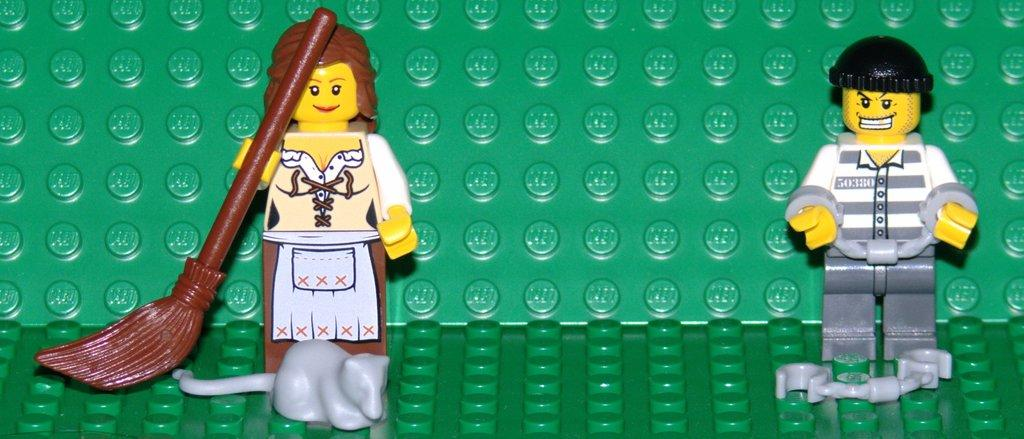What type of toys are present in the image? The toys in the image are made of Lego sets. Can you describe the material used to create these toys? The toys are made of plastic pieces that can be connected to form various structures and figures. What might be the purpose of these Lego toys? The Lego toys can be used for creative play, building, and imagination. What type of bird can be seen perched on the goat's back in the image? There is no bird or goat present in the image; it features toys made of Lego sets. 